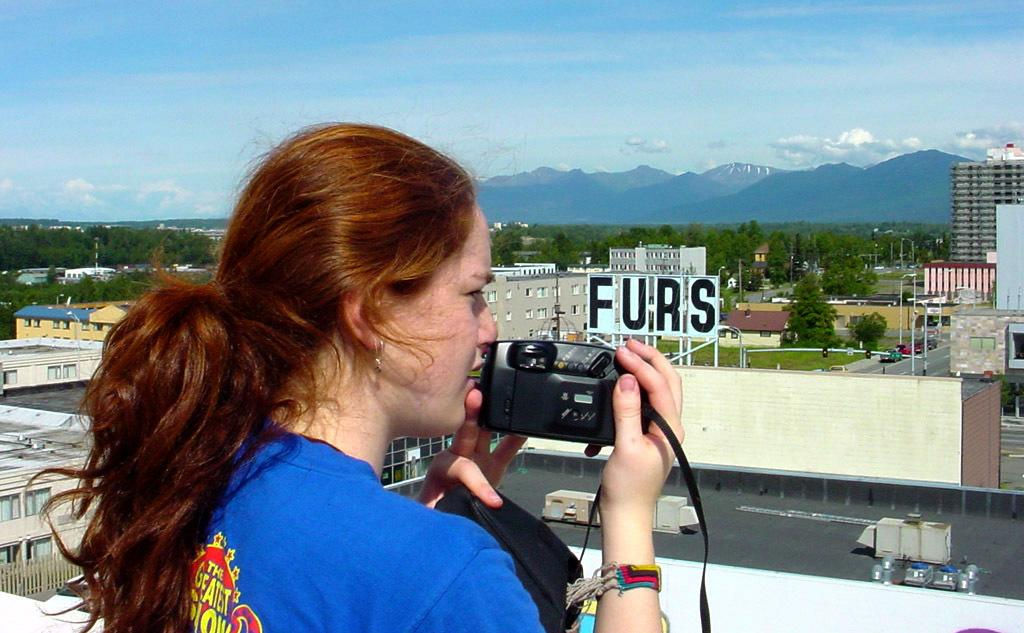Who is the main subject in the image? There is a woman in the image. What is the woman wearing? The woman is wearing a blue shirt. What is the woman holding in the image? The woman is holding a camera. What can be seen in the background of the image? There are buildings, trees, mountains, and the sky visible in the background of the image. What advice does the woman give about cooking celery in the image? There is no mention of celery or advice in the image; it simply shows a woman holding a camera. What arithmetic problem is the woman solving in the image? There is no arithmetic problem or indication of solving one in the image; it only shows a woman holding a camera. 